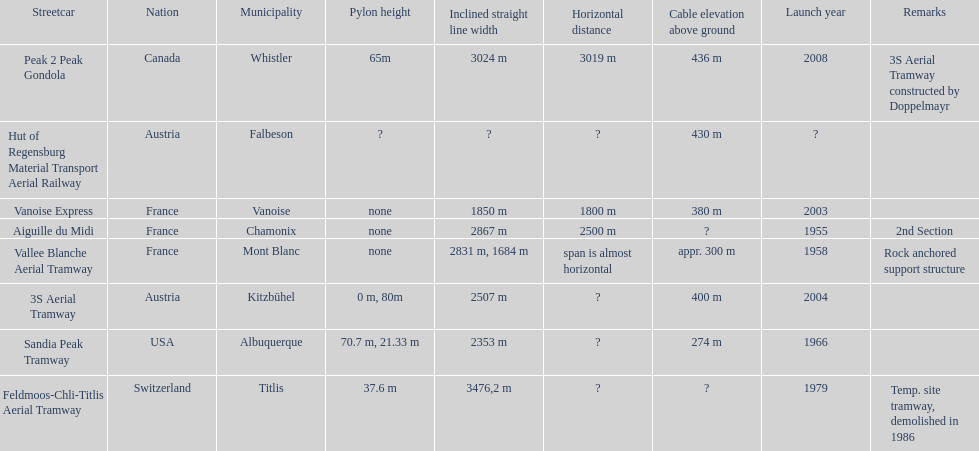Which tramway was built directly before the 3s aeriral tramway? Vanoise Express. 